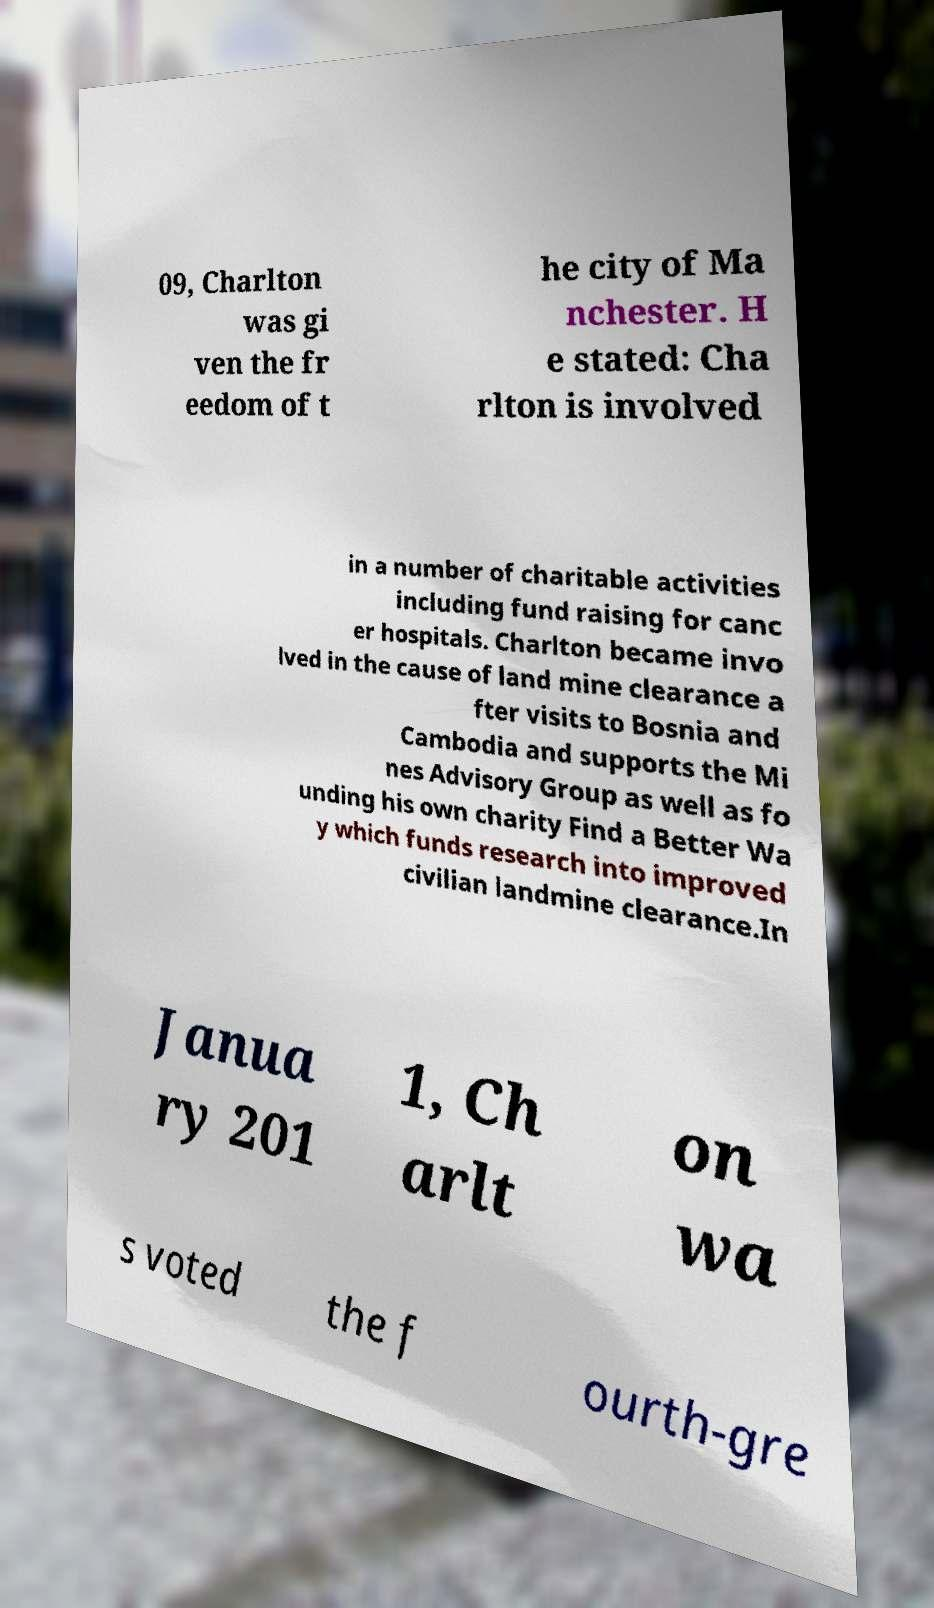Can you accurately transcribe the text from the provided image for me? 09, Charlton was gi ven the fr eedom of t he city of Ma nchester. H e stated: Cha rlton is involved in a number of charitable activities including fund raising for canc er hospitals. Charlton became invo lved in the cause of land mine clearance a fter visits to Bosnia and Cambodia and supports the Mi nes Advisory Group as well as fo unding his own charity Find a Better Wa y which funds research into improved civilian landmine clearance.In Janua ry 201 1, Ch arlt on wa s voted the f ourth-gre 